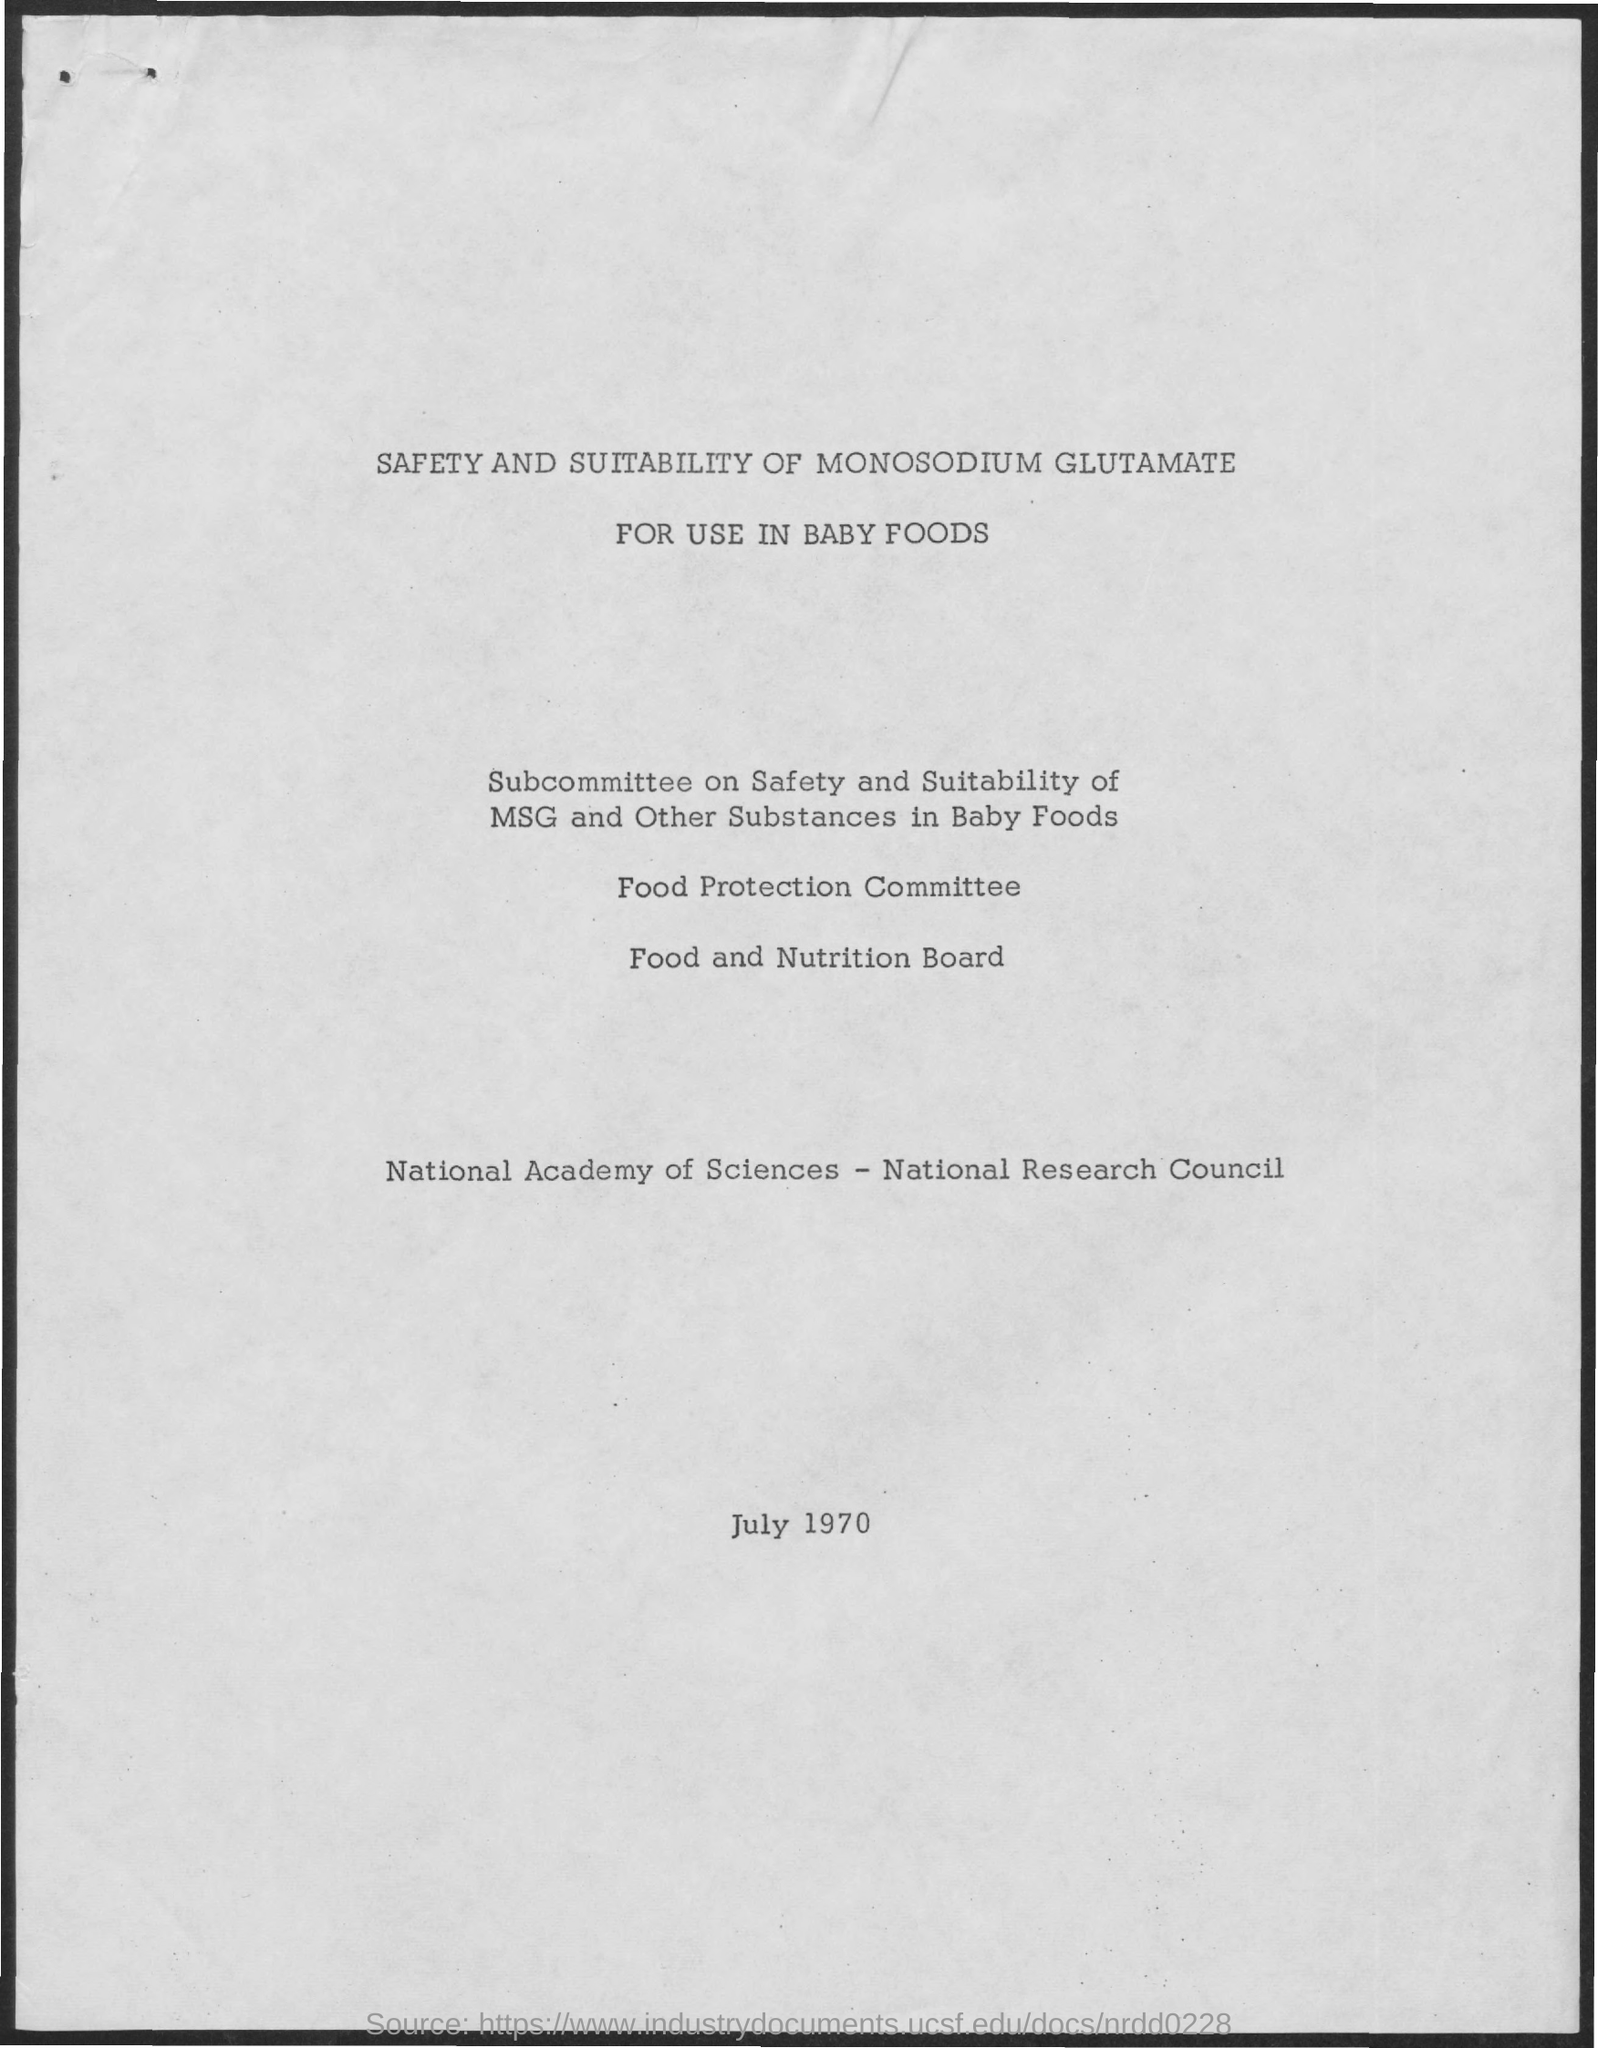Indicate a few pertinent items in this graphic. The document mentions a date of July 1970. 